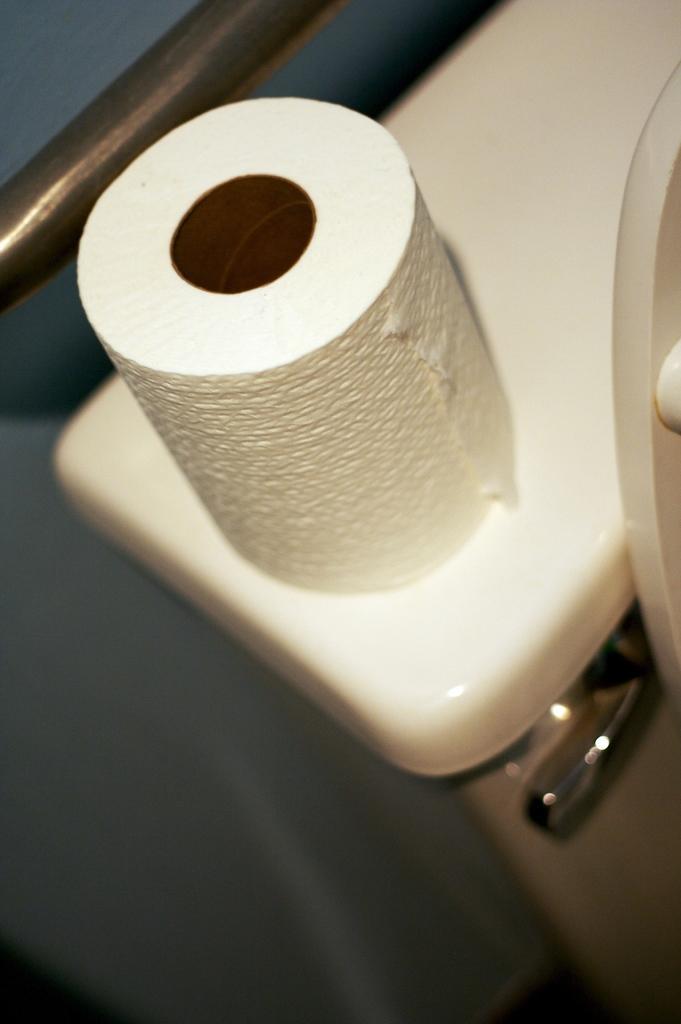Can you describe this image briefly? In this image we can see a tissue paper roll on the object which looks like a toilet. 